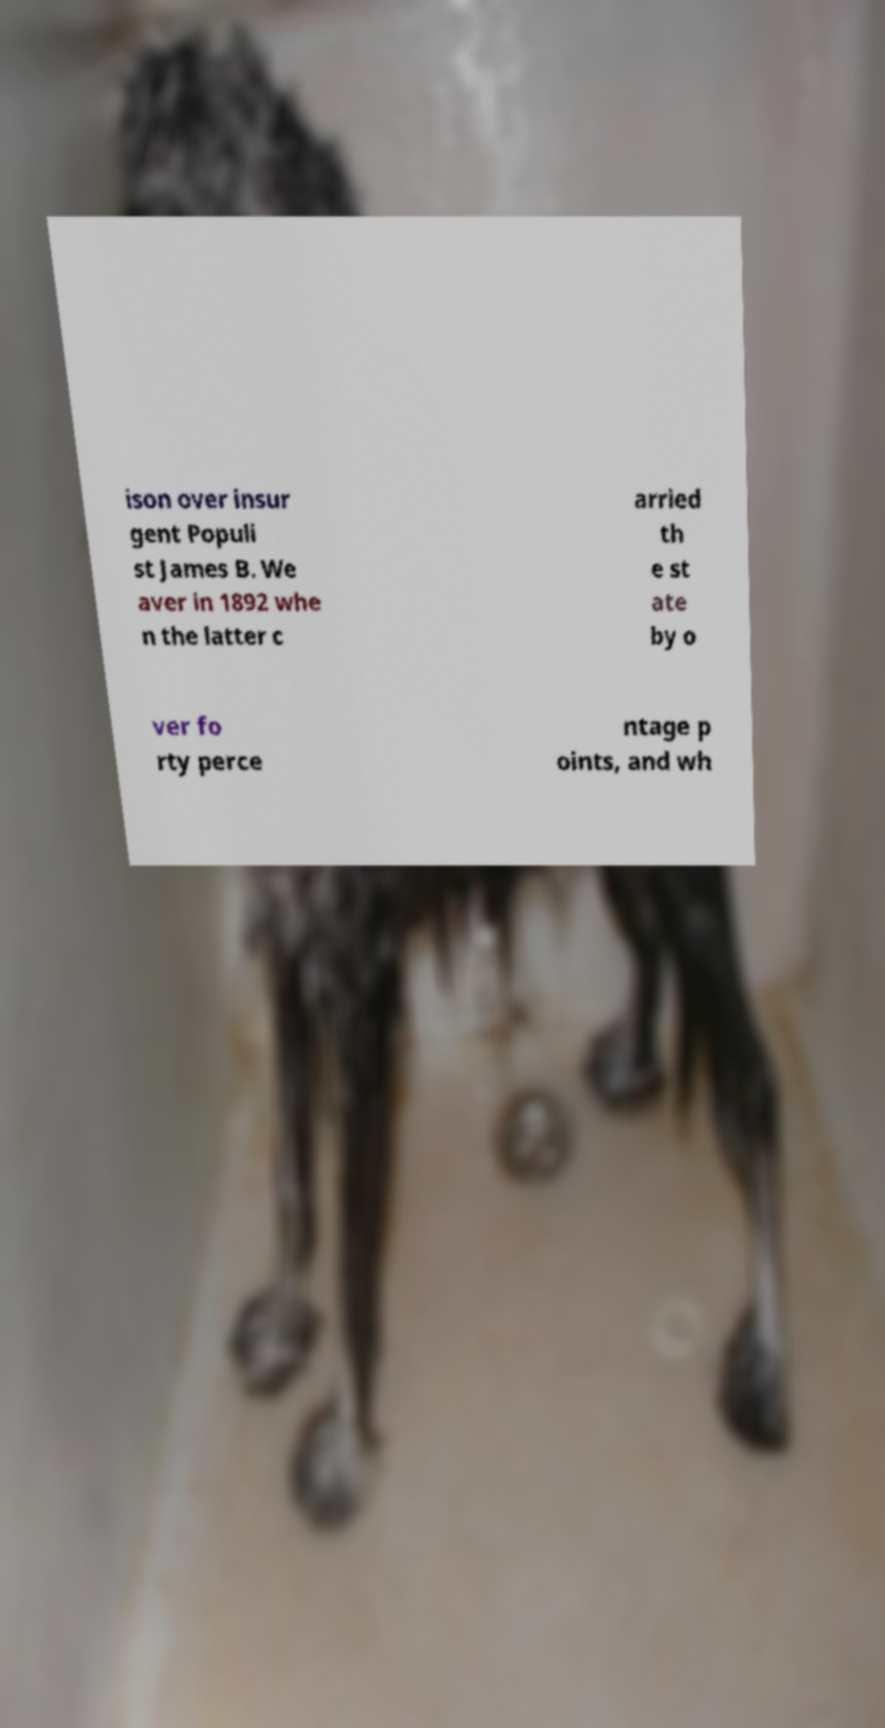Please read and relay the text visible in this image. What does it say? ison over insur gent Populi st James B. We aver in 1892 whe n the latter c arried th e st ate by o ver fo rty perce ntage p oints, and wh 